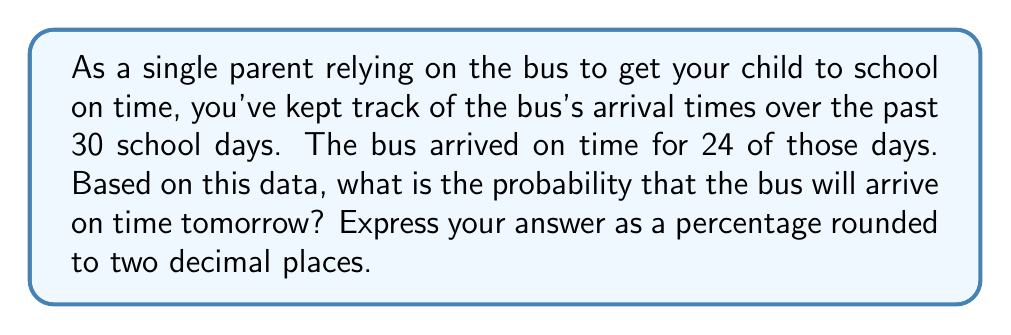What is the answer to this math problem? To solve this problem, we'll use the concept of empirical probability. Empirical probability is based on observed data and is calculated using the following formula:

$$ P(E) = \frac{\text{Number of times event E occurs}}{\text{Total number of observations}} $$

In this case:
- The event E is the bus arriving on time
- The number of times the bus arrived on time is 24
- The total number of observations is 30

Let's plug these values into the formula:

$$ P(\text{Bus arrives on time}) = \frac{24}{30} $$

To simplify this fraction:

$$ \frac{24}{30} = \frac{4}{5} = 0.8 $$

To convert this to a percentage, we multiply by 100:

$$ 0.8 \times 100 = 80\% $$

Therefore, based on the historical data, the probability that the bus will arrive on time tomorrow is 80%.
Answer: 80.00% 